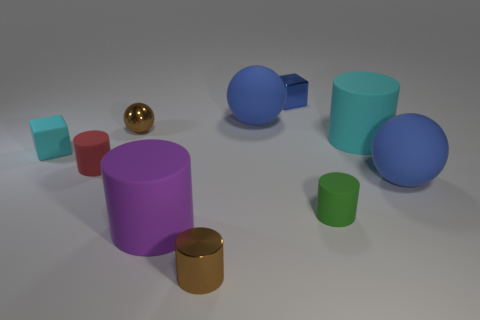Subtract all tiny brown metal balls. How many balls are left? 2 Subtract all brown blocks. How many blue balls are left? 2 Subtract all brown spheres. How many spheres are left? 2 Subtract 2 spheres. How many spheres are left? 1 Subtract all cubes. How many objects are left? 8 Subtract all green cubes. Subtract all cyan cylinders. How many cubes are left? 2 Subtract all big brown metal balls. Subtract all large balls. How many objects are left? 8 Add 1 large objects. How many large objects are left? 5 Add 2 cylinders. How many cylinders exist? 7 Subtract 1 green cylinders. How many objects are left? 9 